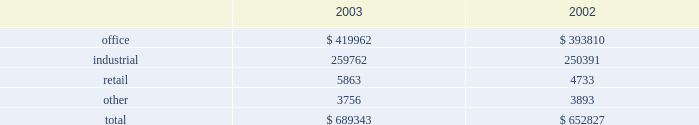Gain on land sales are derived from sales of undeveloped land owned by us .
We pursue opportunities to dispose of land in markets with a high concentration of undeveloped land and in those markets where the land no longer meets our strategic development plans .
The increase was partially attributable to a land sale to a current corporate tenant for potential future expansion .
We recorded $ 424000 and $ 560000 of impairment charges associated with contracts to sell land parcels for the years ended december 31 , 2004 and 2003 , respectively .
As of december 31 , 2004 , only one parcel on which we recorded impairment charges is still owned by us .
We anticipate selling this parcel in the first quarter of 2005 .
Discontinued operations we have classified operations of 86 buildings as discontinued operations as of december 31 , 2004 .
These 86 buildings consist of 69 industrial , 12 office and five retail properties .
As a result , we classified net income from operations , net of minority interest , of $ 1.6 million , $ 6.3 million and $ 10.7 million as net income from discontinued operations for the years ended december 31 , 2004 , 2003 and 2002 , respectively .
In addition , 41 of the properties classified in discontinued operations were sold during 2004 , 42 properties were sold during 2003 , two properties were sold during 2002 and one operating property is classified as held-for-sale at december 31 , 2004 .
The gains on disposal of these properties , net of impairment adjustment and minority interest , of $ 23.9 million and $ 11.8 million for the years ended december 31 , 2004 and 2003 , respectively , are also reported in discontinued operations .
For the year ended december 31 , 2002 , a $ 4.5 million loss on disposal of properties , net of impairment adjustments and minority interest , is reported in discontinued operations due to impairment charges of $ 7.7 million recorded on three properties in 2002 that were later sold in 2003 and 2004 .
Comparison of year ended december 31 , 2003 to year ended december 31 , 2002 rental income from continuing operations rental income from continuing operations increased from $ 652.8 million in 2002 to $ 689.3 million in 2003 .
The table reconciles rental income by reportable segment to our total reported rental income from continuing operations for the years ended december 31 , 2003 and 2002 ( in thousands ) : .
Although our three reportable segments comprising rental operations ( office , industrial and retail ) are all within the real estate industry , they are not necessarily affected by the same economic and industry conditions .
For example , our retail segment experienced high occupancies and strong overall performance during 2003 , while our office and industrial segments reflected the weaker economic environment for those property types .
The primary causes of the increase in rental income from continuing operations , with specific references to a particular segment when applicable , are summarized below : 25cf during 2003 , in-service occupancy improved from 87.1% ( 87.1 % ) at the end of 2002 to 89.3% ( 89.3 % ) at the end of 2003 .
The second half of 2003 was highlighted by a significant increase in the industrial portfolio occupancy of 2.1% ( 2.1 % ) along with a slight increase in office portfolio occupancy of 0.9% ( 0.9 % ) .
25cf lease termination fees totaled $ 27.4 million in 2002 compared to $ 16.2 million in 2003 .
Most of this decrease was attributable to the office segment , which recognized $ 21.1 million of termination fees in 2002 as compared to $ 11.8 million in 2003 .
Lease termination fees relate to specific tenants that pay a fee to terminate their lease obligations before the end of the contractual lease term .
The high volume of termination fees in 2002 was reflective of the contraction of the business of large office users during that year and their desire to downsize their use of office space .
The decrease in termination fees for 2003 was indicative of an improving economy and a more stable financial position of our tenants .
25cf during the year ended 2003 , we acquired $ 232 million of properties totaling 2.1 million square feet .
The acquisitions were primarily class a office buildings in existing markets with overall occupancy near 90% ( 90 % ) .
Revenues associated with these acquisitions totaled $ 11.9 million in 2003 .
In addition , revenues from 2002 acquisitions totaled $ 15.8 million in 2003 compared to $ 4.8 million in 2002 .
This significant increase is primarily due to a large office acquisition that closed at the end of december 2002 .
25cf developments placed in-service in 2003 provided revenues of $ 6.6 million , while revenues associated with developments placed in-service in 2002 totaled $ 13.7 million in 2003 compared to $ 4.7 million in 25cf proceeds from dispositions of held for rental properties totaled $ 126.1 million in 2003 , compared to $ 40.9 million in 2002 .
These properties generated revenue of $ 12.5 million in 2003 versus $ 19.6 million in 2002 .
Equity in earnings of unconsolidated companies equity in earnings represents our ownership share of net income from investments in unconsolidated companies .
These joint ventures generally own and operate rental properties and hold land for development .
These earnings decreased from $ 27.2 million in 2002 to $ 23.7 million in 2003 .
This decrease is a result of the following significant activity: .
What was the total of impairment charges associated with contracts to sell land parcels for the years ended december 31 , 2004 and 2003 , respectively .? 
Computations: (424000 + 560000)
Answer: 984000.0. 